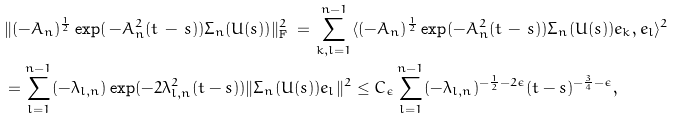Convert formula to latex. <formula><loc_0><loc_0><loc_500><loc_500>& \| ( - A _ { n } ) ^ { \frac { 1 } { 2 } } \exp ( \, - A _ { n } ^ { 2 } ( t \, - \, s ) ) \Sigma _ { n } ( U ( s ) ) \| ^ { 2 } _ { \mathrm F } \, = \, \sum _ { k , l = 1 } ^ { n - 1 } \langle ( - A _ { n } ) ^ { \frac { 1 } { 2 } } \exp ( - A _ { n } ^ { 2 } ( t \, - \, s ) ) \Sigma _ { n } ( U ( s ) ) e _ { k } , e _ { l } \rangle ^ { 2 } \\ & = \sum _ { l = 1 } ^ { n - 1 } ( - \lambda _ { l , n } ) \exp ( - 2 \lambda ^ { 2 } _ { l , n } ( t - s ) ) \| \Sigma _ { n } ( U ( s ) ) e _ { l } \| ^ { 2 } \leq C _ { \epsilon } \sum _ { l = 1 } ^ { n - 1 } ( - \lambda _ { l , n } ) ^ { - \frac { 1 } { 2 } - 2 \epsilon } ( t - s ) ^ { - \frac { 3 } { 4 } - \epsilon } ,</formula> 